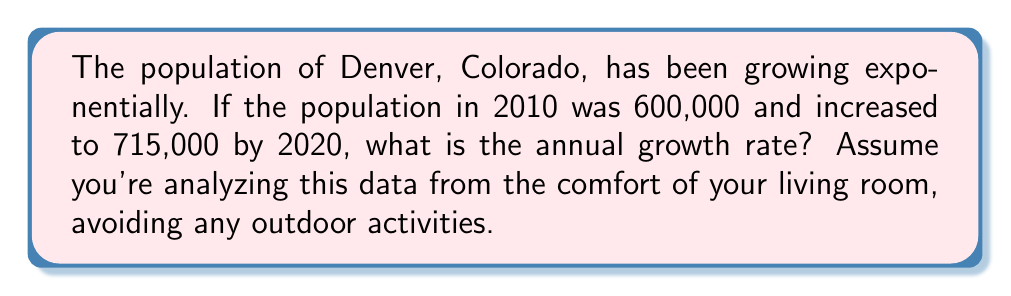Could you help me with this problem? Let's approach this step-by-step:

1) The exponential growth formula is:
   $$P(t) = P_0 \cdot (1 + r)^t$$
   where $P(t)$ is the population at time $t$, $P_0$ is the initial population, $r$ is the annual growth rate, and $t$ is the time in years.

2) We know:
   $P_0 = 600,000$ (population in 2010)
   $P(10) = 715,000$ (population in 2020)
   $t = 10$ years

3) Plugging these into the formula:
   $$715,000 = 600,000 \cdot (1 + r)^{10}$$

4) Dividing both sides by 600,000:
   $$\frac{715,000}{600,000} = (1 + r)^{10}$$

5) Simplifying:
   $$1.191667 = (1 + r)^{10}$$

6) Taking the 10th root of both sides:
   $$\sqrt[10]{1.191667} = 1 + r$$

7) Subtracting 1 from both sides:
   $$\sqrt[10]{1.191667} - 1 = r$$

8) Calculating:
   $$r \approx 0.0177 \text{ or } 1.77\%$$
Answer: 1.77% 